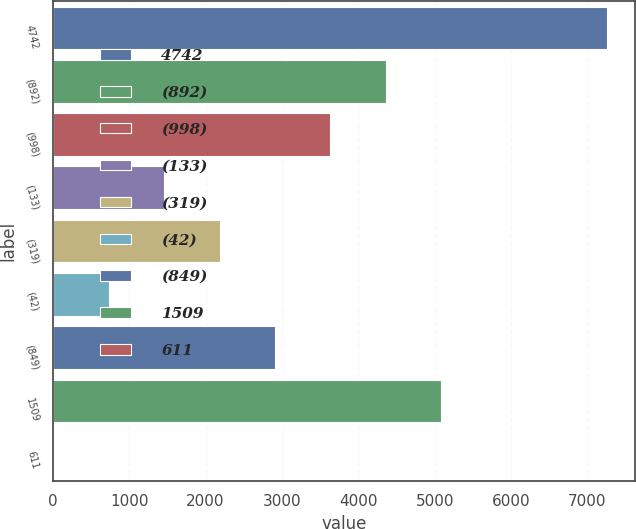<chart> <loc_0><loc_0><loc_500><loc_500><bar_chart><fcel>4742<fcel>(892)<fcel>(998)<fcel>(133)<fcel>(319)<fcel>(42)<fcel>(849)<fcel>1509<fcel>611<nl><fcel>7262<fcel>4360.12<fcel>3634.66<fcel>1458.28<fcel>2183.74<fcel>732.82<fcel>2909.2<fcel>5085.58<fcel>7.36<nl></chart> 